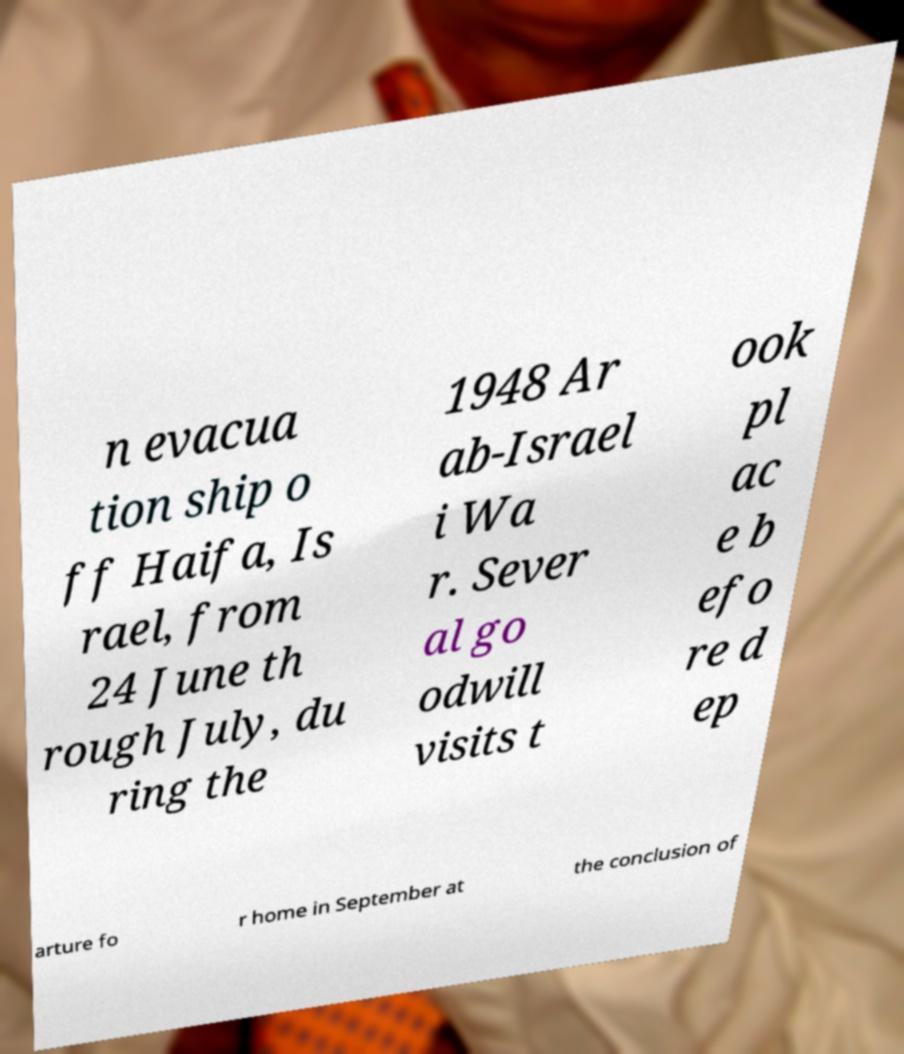What messages or text are displayed in this image? I need them in a readable, typed format. n evacua tion ship o ff Haifa, Is rael, from 24 June th rough July, du ring the 1948 Ar ab-Israel i Wa r. Sever al go odwill visits t ook pl ac e b efo re d ep arture fo r home in September at the conclusion of 